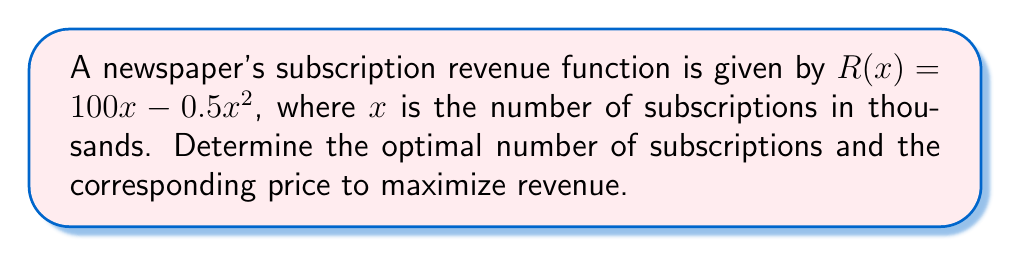What is the answer to this math problem? 1. To find the optimal number of subscriptions, we need to find the maximum point of the revenue function. This occurs where the derivative of the revenue function equals zero.

2. Calculate the derivative of the revenue function:
   $$R'(x) = 100 - x$$

3. Set the derivative equal to zero and solve for x:
   $$100 - x = 0$$
   $$x = 100$$

4. This means the optimal number of subscriptions is 100,000 (remember x is in thousands).

5. To find the corresponding price, we need to use the concept of marginal revenue. At the optimal point, marginal revenue equals price.

6. The marginal revenue function is the derivative of the revenue function:
   $$MR(x) = R'(x) = 100 - x$$

7. Substitute the optimal number of subscriptions:
   $$MR(100) = 100 - 100 = 0$$

8. Therefore, the optimal price is $0 per subscription.

9. To verify this is a maximum (not a minimum), check the second derivative:
   $$R''(x) = -1 < 0$$
   This confirms we have found a maximum.
Answer: 100,000 subscriptions at $0 each 